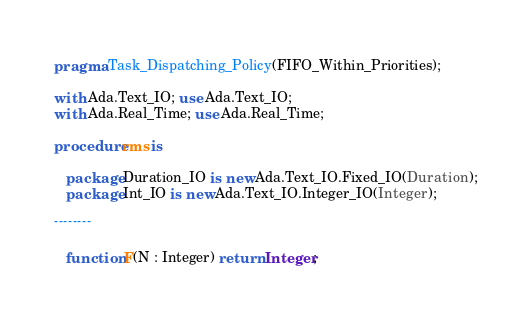<code> <loc_0><loc_0><loc_500><loc_500><_Ada_>pragma Task_Dispatching_Policy(FIFO_Within_Priorities);

with Ada.Text_IO; use Ada.Text_IO;
with Ada.Real_Time; use Ada.Real_Time;

procedure rms is

   package Duration_IO is new Ada.Text_IO.Fixed_IO(Duration);
   package Int_IO is new Ada.Text_IO.Integer_IO(Integer);

--------

   function F(N : Integer) return Integer;
</code> 